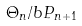<formula> <loc_0><loc_0><loc_500><loc_500>\Theta _ { n } / b P _ { n + 1 }</formula> 